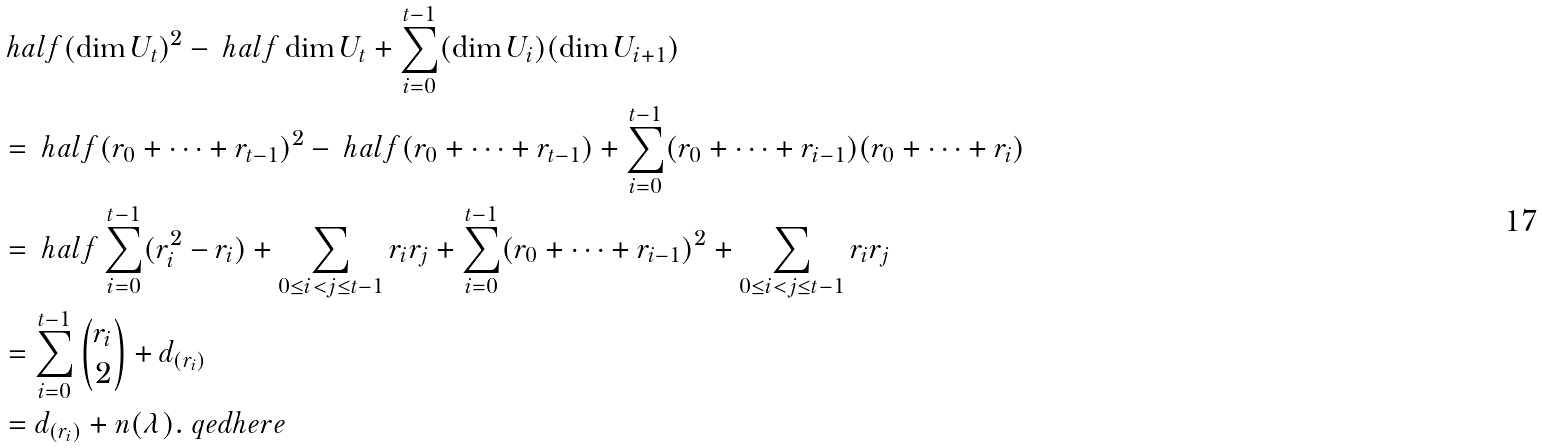Convert formula to latex. <formula><loc_0><loc_0><loc_500><loc_500>& \ h a l f ( \dim U _ { t } ) ^ { 2 } - \ h a l f \dim U _ { t } + \sum _ { i = 0 } ^ { t - 1 } ( \dim U _ { i } ) ( \dim U _ { i + 1 } ) \\ & = \ h a l f ( r _ { 0 } + \cdots + r _ { t - 1 } ) ^ { 2 } - \ h a l f ( r _ { 0 } + \cdots + r _ { t - 1 } ) + \sum _ { i = 0 } ^ { t - 1 } ( r _ { 0 } + \cdots + r _ { i - 1 } ) ( r _ { 0 } + \cdots + r _ { i } ) \\ & = \ h a l f \sum _ { i = 0 } ^ { t - 1 } ( r _ { i } ^ { 2 } - r _ { i } ) + \sum _ { 0 \leq i < j \leq t - 1 } r _ { i } r _ { j } + \sum _ { i = 0 } ^ { t - 1 } ( r _ { 0 } + \cdots + r _ { i - 1 } ) ^ { 2 } + \sum _ { 0 \leq i < j \leq t - 1 } r _ { i } r _ { j } \\ & = \sum _ { i = 0 } ^ { t - 1 } \binom { r _ { i } } { 2 } + d _ { ( r _ { i } ) } \\ & = d _ { ( r _ { i } ) } + n ( \lambda ) . \ q e d h e r e</formula> 